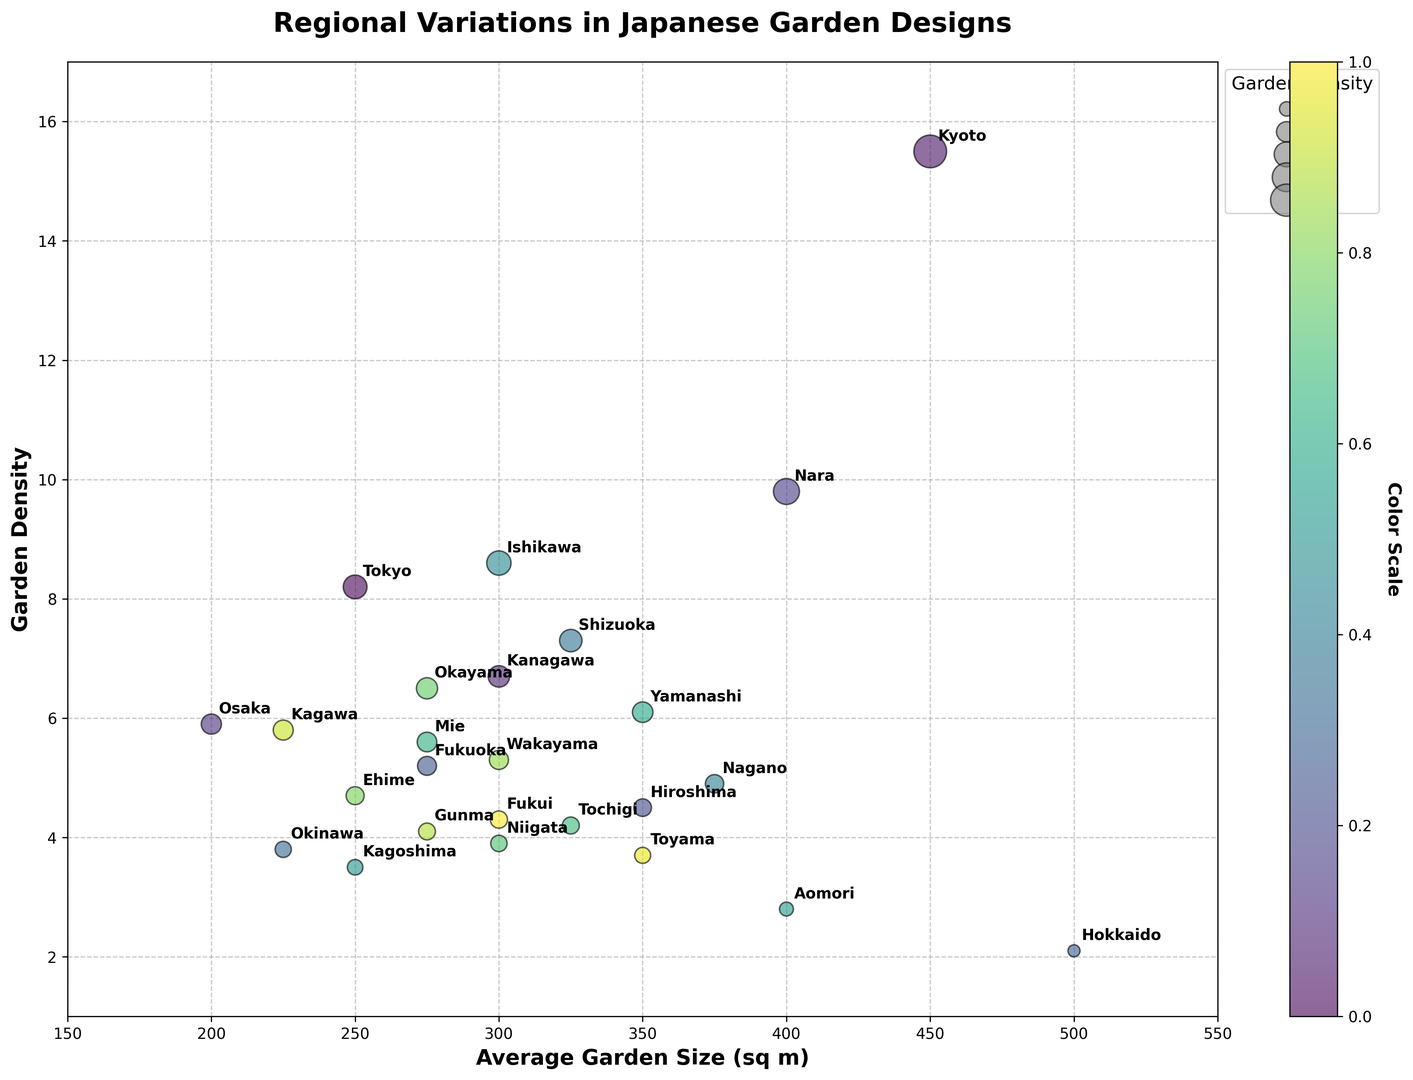Which prefecture has the highest garden density? By observing the y-axis, identify the prefecture located at the highest point. Kyoto is at the highest point on the y-axis.
Answer: Kyoto What is the average garden size of Tokyo? Locate Tokyo on the plot, identify its position on the x-axis corresponding to the average garden size. Tokyo aligns with the 250 mark on the x-axis.
Answer: 250 sq m Which garden style has the largest average garden size? Identify the bubbles positioned furthest to the right on the x-axis and check their corresponding labels and styles. Hokkaido, with the Natural style, is the furthest to the right at 500 sq m.
Answer: Natural Compare the garden density between Kanagawa and Fukuoka. Which one is higher? Locate both prefectures on the plot and compare their positions on the y-axis. Kanagawa is positioned higher on the y-axis than Fukuoka.
Answer: Kanagawa What is the combined garden density of Hokkaido and Okinawa? Identify their respective garden densities, then sum them up. Hokkaido density is 2.1, and Okinawa is 3.8. So, 2.1 + 3.8 = 5.9.
Answer: 5.9 Which prefecture, Nara or Osaka, has a larger average garden size? Locate both prefectures on the plot and compare their positions on the x-axis. Nara is positioned further right than Osaka.
Answer: Nara Is there any prefecture with an average garden size of exactly 300 sq m? Identify the bubbles exactly aligned with the 300 mark on the x-axis and check their corresponding labels. Prefectures Kanagawa, Ishikawa, Okayama, Niigata, and Wakayama are at 300 sq m.
Answer: Yes What is the dominant garden style in Kagoshima? Locate Kagoshima on the plot and read its label to find the dominant style. Kagoshima is marked with the Volcanic style.
Answer: Volcanic Which prefectures have garden densities greater than 6 but less than 10? Identify bubbles positioned between 6 and 10 on the y-axis and check their corresponding labels. Prefectures Tokyo, Kanagawa, Nara, and Ishikawa are between 6 and 10.
Answer: Tokyo, Kanagawa, Nara, Ishikawa Is there a correlation between average garden size and garden density? Observe the general trend of the bubbles on the plot; they do not show a strong positive or negative correlation. The distribution seems scattered, indicating no obvious correlation.
Answer: No clear correlation 